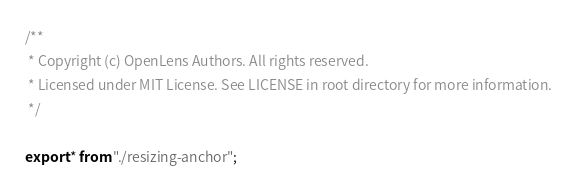<code> <loc_0><loc_0><loc_500><loc_500><_TypeScript_>/**
 * Copyright (c) OpenLens Authors. All rights reserved.
 * Licensed under MIT License. See LICENSE in root directory for more information.
 */

export * from "./resizing-anchor";
</code> 